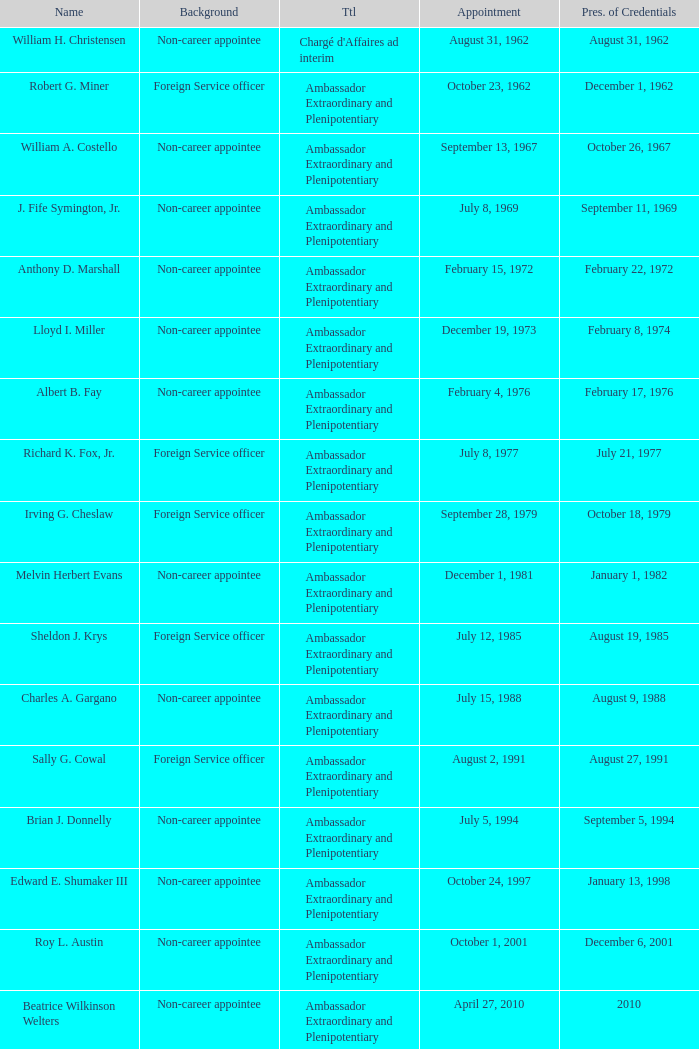What was Anthony D. Marshall's title? Ambassador Extraordinary and Plenipotentiary. 